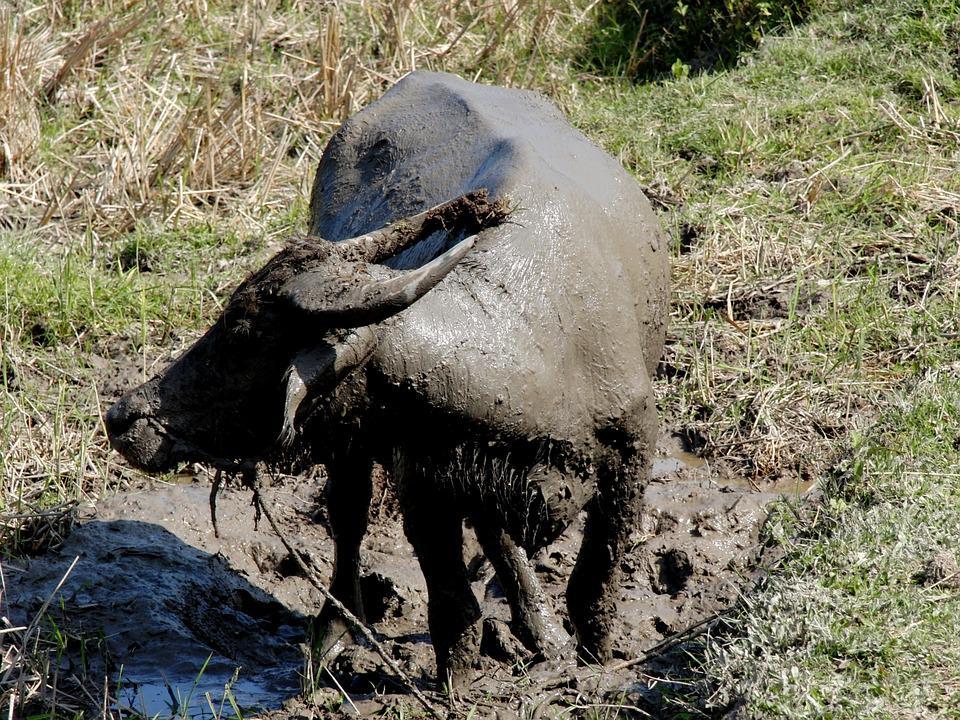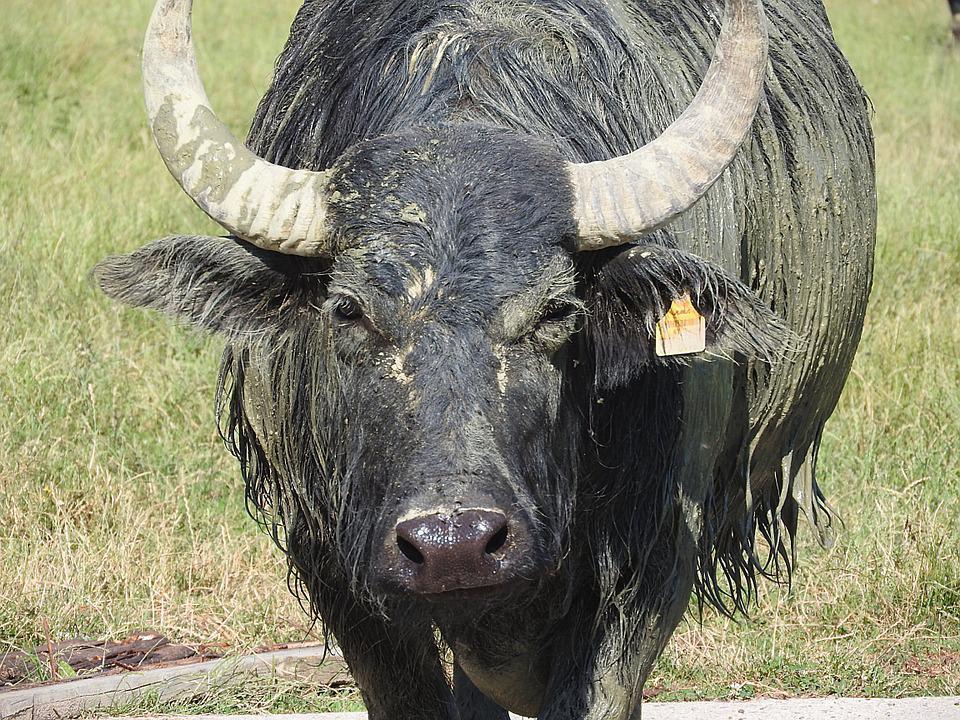The first image is the image on the left, the second image is the image on the right. Assess this claim about the two images: "An image shows an ox-type animal in the mud.". Correct or not? Answer yes or no. Yes. 